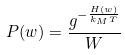Convert formula to latex. <formula><loc_0><loc_0><loc_500><loc_500>P ( w ) = \frac { g ^ { - \frac { H ( w ) } { k _ { M } T } } } { W }</formula> 